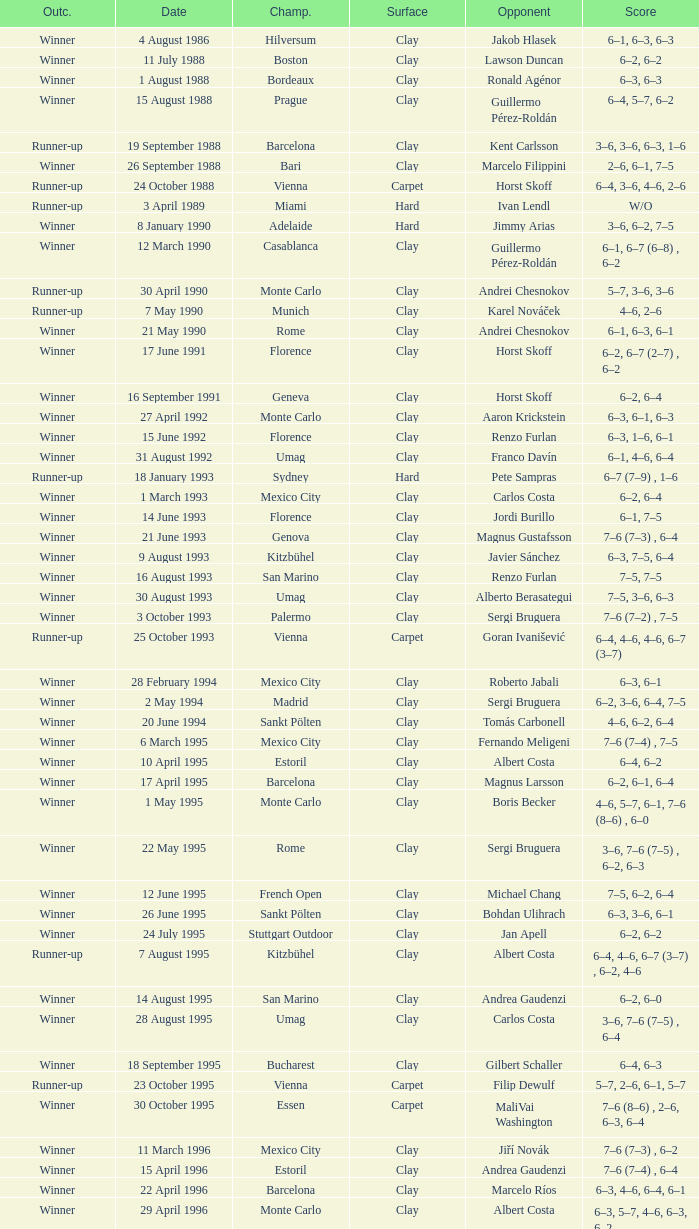In the championship, what is the score when rome faces richard krajicek as the opponent? 6–2, 6–4, 3–6, 6–3. 